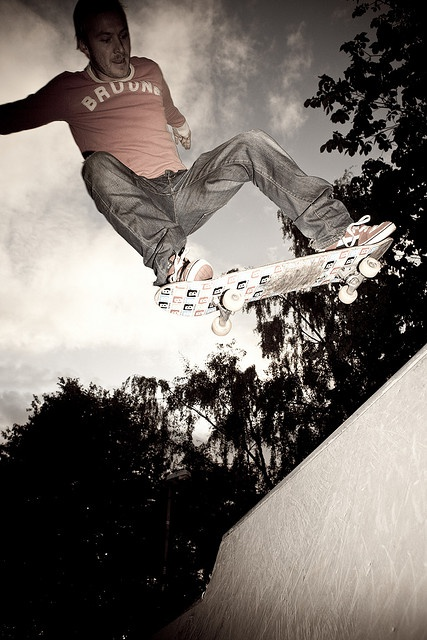Describe the objects in this image and their specific colors. I can see people in black, gray, and darkgray tones and skateboard in black, white, darkgray, tan, and lightgray tones in this image. 